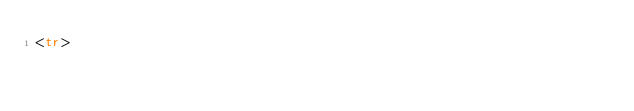Convert code to text. <code><loc_0><loc_0><loc_500><loc_500><_HTML_><tr></code> 